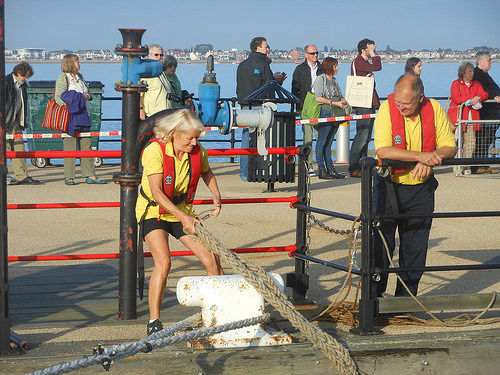<image>
Is the women on the rope? No. The women is not positioned on the rope. They may be near each other, but the women is not supported by or resting on top of the rope. Where is the woman in relation to the fence? Is it behind the fence? Yes. From this viewpoint, the woman is positioned behind the fence, with the fence partially or fully occluding the woman. 